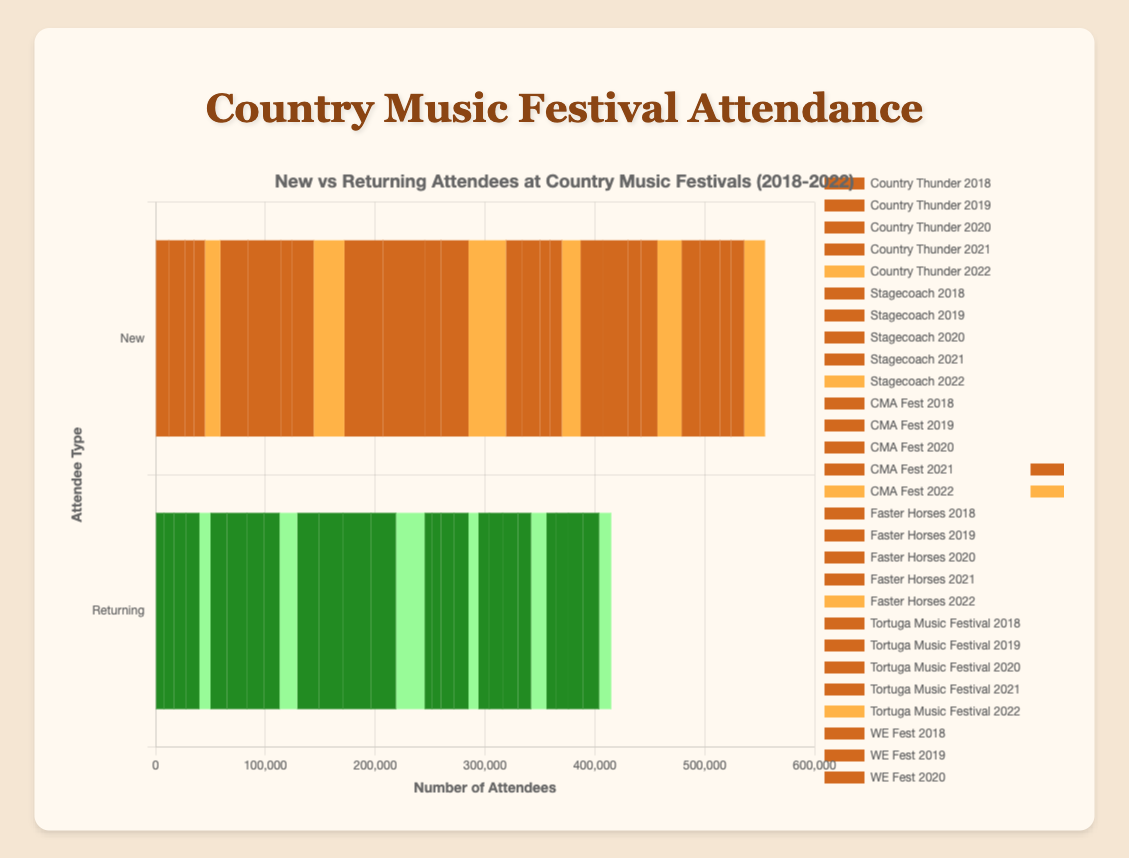What year had the highest number of new attendees at the CMA Fest? To determine which year had the highest number of new attendees at the CMA Fest, compare the new attendee numbers for each year: 2018 (35,000), 2019 (38,000), 2020 (15,000), 2021 (25,000), and 2022 (34,000). 2019 has the highest number: 38,000.
Answer: 2019 How did the number of returning attendees at Stagecoach change from 2018 to 2019? To find the change for returning attendees at Stagecoach from 2018 to 2019, look at the numbers: 2018 (15,000) and 2019 (18,000). The change is 18000 - 15000 = 3,000.
Answer: increased by 3,000 Which festival had the lowest combined total of new and returning attendees in 2020? Add the new and returning attendees for each festival in 2020: Country Thunder (8,000 + 11,000 = 19,000), Stagecoach (10,000 + 16,000 = 26,000), CMA Fest (15,000 + 25,000 = 40,000), Faster Horses (9,000 + 12,000 = 21,000), Tortuga Music Festival (12,000 + 14,000 = 26,000), WE Fest (10,000 + 13,000 = 23,000). Country Thunder has the lowest total: 19,000.
Answer: Country Thunder In which year did Faster Horses have more new attendees than returning attendees? Examine the new vs. returning numbers for Faster Horses from 2018 to 2022: 2018 (15,000 vs. 7,000), 2019 (16,000 vs. 8,000), 2020 (9,000 vs. 12,000), 2021 (11,000 vs. 13,000), 2022 (17,000 vs. 9,000). The years 2018, 2019, and 2022 had more new attendees.
Answer: 2018, 2019, 2022 What is the average number of new attendees across all festivals for the year 2018? Sum up the new attendees for all festivals in 2018 and divide by the number of festivals: Country Thunder (12,000), Stagecoach (25,000), CMA Fest (35,000), Faster Horses (15,000), Tortuga Music Festival (20,000), WE Fest (17,000). Total = 12,000 + 25,000 + 35,000 + 15,000 + 20,000 + 17,000 = 124,000. The average is 124,000 / 6 = 20,666.67.
Answer: 20,666.67 If you combined the numbers of new and returning attendees at WE Fest in 2022, how would it compare to the total attendees of CMA Fest in 2020? WE Fest 2022: 19,000 (New) + 11,000 (Returning) = 30,000. CMA Fest 2020: 15,000 (New) + 25,000 (Returning) = 40,000. WE Fest in 2022 has 30,000 total, which is 10,000 fewer than CMA Fest in 2020's 40,000.
Answer: 10,000 fewer Between 2020 and 2021, which festival saw the largest increase in new attendees? Calculate the change in new attendees for each festival between 2020 and 2021: Country Thunder (10,000 - 8,000 = 2,000), Stagecoach (20,000 - 10,000 = 10,000), CMA Fest (25,000 - 15,000 = 10,000), Faster Horses (11,000 - 9,000 = 2,000), Tortuga Music Festival (15,000 - 12,000 = 3,000), WE Fest (12,000 - 10,000 = 2,000). The largest increase is shared by Stagecoach and CMA Fest with 10,000.
Answer: Stagecoach and CMA Fest 